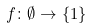Convert formula to latex. <formula><loc_0><loc_0><loc_500><loc_500>f \colon \emptyset \to \{ 1 \}</formula> 